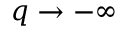Convert formula to latex. <formula><loc_0><loc_0><loc_500><loc_500>q \to - \infty</formula> 